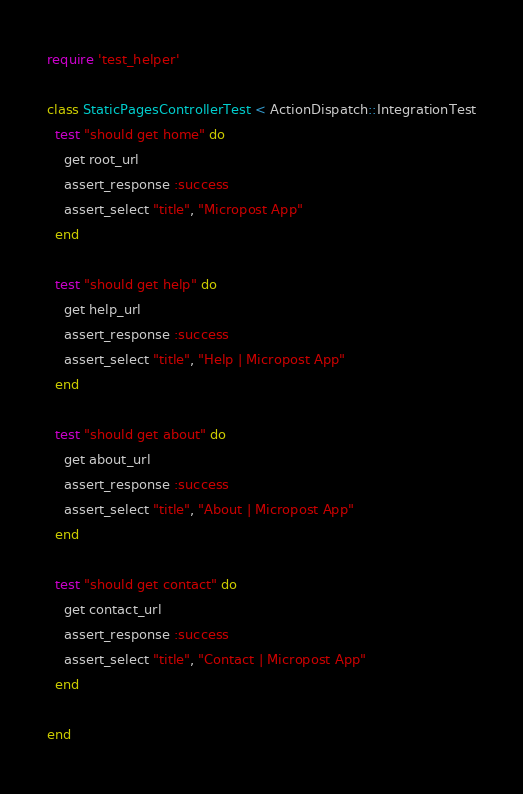<code> <loc_0><loc_0><loc_500><loc_500><_Ruby_>require 'test_helper'

class StaticPagesControllerTest < ActionDispatch::IntegrationTest
  test "should get home" do
    get root_url
    assert_response :success
    assert_select "title", "Micropost App"
  end

  test "should get help" do
    get help_url
    assert_response :success
    assert_select "title", "Help | Micropost App"
  end

  test "should get about" do
    get about_url
    assert_response :success
    assert_select "title", "About | Micropost App"
  end

  test "should get contact" do
    get contact_url
    assert_response :success
    assert_select "title", "Contact | Micropost App"
  end

end
</code> 